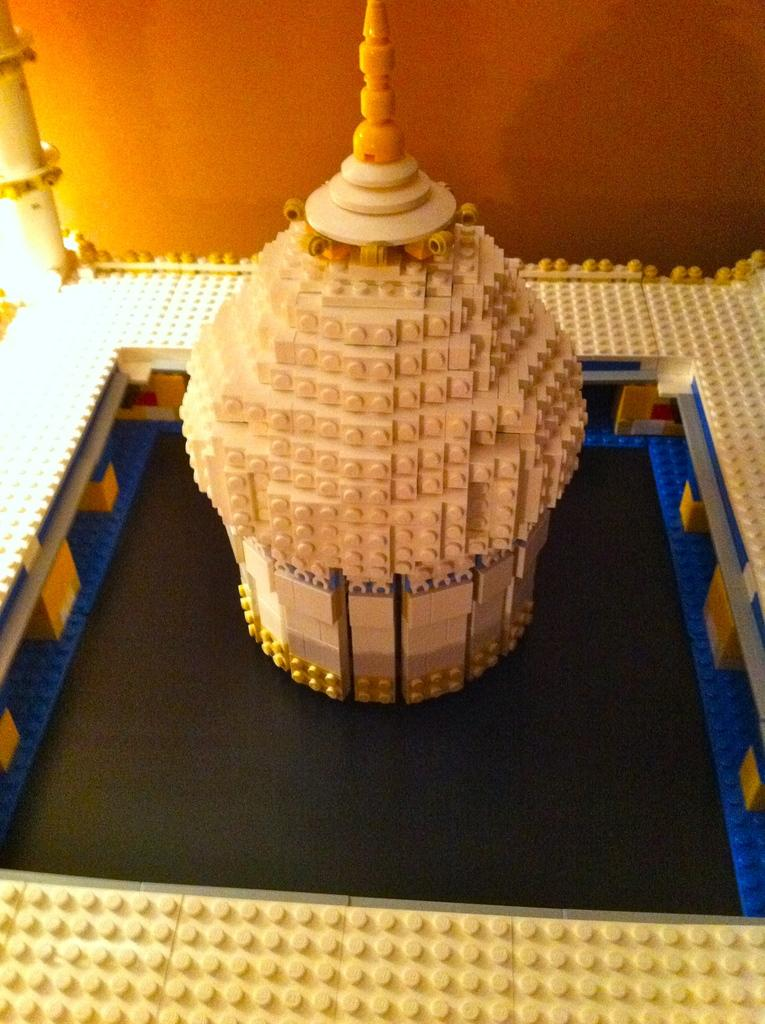What type of structure is visible in the image? There is a building in the image. What can be seen in the background of the image? There is a wall in the background of the image. What type of cart is being used to transport goods in the image? There is no cart present in the image; it only features a building and a wall in the background. 